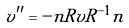Convert formula to latex. <formula><loc_0><loc_0><loc_500><loc_500>v ^ { \prime \prime } = - n R v R ^ { - 1 } n</formula> 